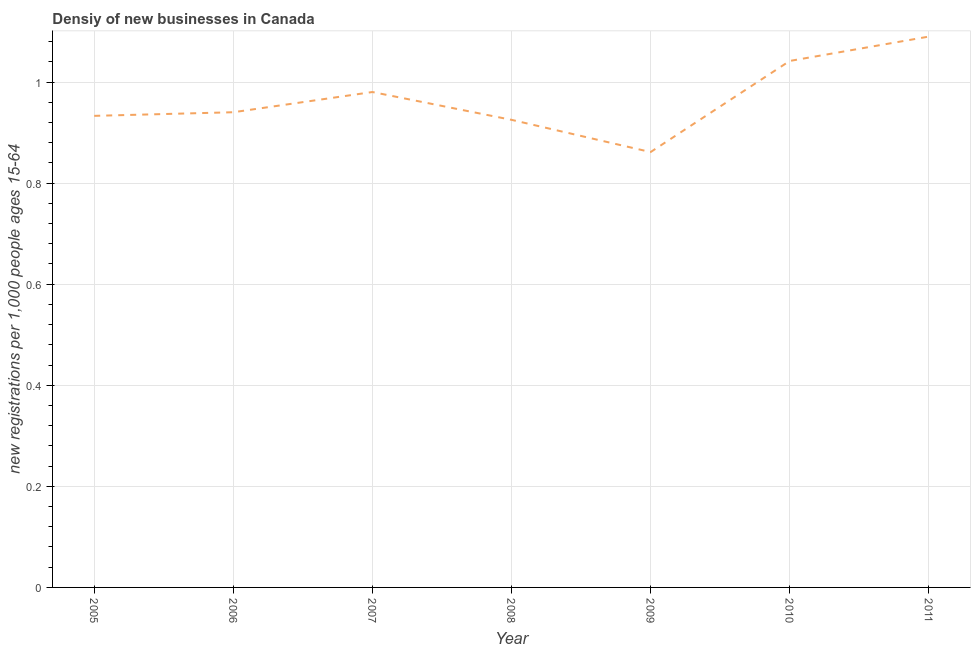What is the density of new business in 2007?
Offer a terse response. 0.98. Across all years, what is the maximum density of new business?
Keep it short and to the point. 1.09. Across all years, what is the minimum density of new business?
Your answer should be very brief. 0.86. What is the sum of the density of new business?
Provide a short and direct response. 6.77. What is the difference between the density of new business in 2005 and 2011?
Your answer should be very brief. -0.16. What is the average density of new business per year?
Your answer should be compact. 0.97. What is the median density of new business?
Your answer should be very brief. 0.94. In how many years, is the density of new business greater than 0.48000000000000004 ?
Provide a succinct answer. 7. What is the ratio of the density of new business in 2005 to that in 2006?
Provide a short and direct response. 0.99. Is the difference between the density of new business in 2005 and 2011 greater than the difference between any two years?
Provide a succinct answer. No. What is the difference between the highest and the second highest density of new business?
Keep it short and to the point. 0.05. Is the sum of the density of new business in 2005 and 2010 greater than the maximum density of new business across all years?
Your answer should be very brief. Yes. What is the difference between the highest and the lowest density of new business?
Your response must be concise. 0.23. How many years are there in the graph?
Keep it short and to the point. 7. Does the graph contain any zero values?
Ensure brevity in your answer.  No. What is the title of the graph?
Your response must be concise. Densiy of new businesses in Canada. What is the label or title of the Y-axis?
Your answer should be compact. New registrations per 1,0 people ages 15-64. What is the new registrations per 1,000 people ages 15-64 in 2005?
Ensure brevity in your answer.  0.93. What is the new registrations per 1,000 people ages 15-64 in 2006?
Provide a short and direct response. 0.94. What is the new registrations per 1,000 people ages 15-64 in 2007?
Keep it short and to the point. 0.98. What is the new registrations per 1,000 people ages 15-64 of 2008?
Your answer should be compact. 0.93. What is the new registrations per 1,000 people ages 15-64 in 2009?
Offer a very short reply. 0.86. What is the new registrations per 1,000 people ages 15-64 of 2010?
Ensure brevity in your answer.  1.04. What is the new registrations per 1,000 people ages 15-64 of 2011?
Your answer should be compact. 1.09. What is the difference between the new registrations per 1,000 people ages 15-64 in 2005 and 2006?
Provide a short and direct response. -0.01. What is the difference between the new registrations per 1,000 people ages 15-64 in 2005 and 2007?
Your response must be concise. -0.05. What is the difference between the new registrations per 1,000 people ages 15-64 in 2005 and 2008?
Give a very brief answer. 0.01. What is the difference between the new registrations per 1,000 people ages 15-64 in 2005 and 2009?
Offer a terse response. 0.07. What is the difference between the new registrations per 1,000 people ages 15-64 in 2005 and 2010?
Offer a very short reply. -0.11. What is the difference between the new registrations per 1,000 people ages 15-64 in 2005 and 2011?
Provide a short and direct response. -0.16. What is the difference between the new registrations per 1,000 people ages 15-64 in 2006 and 2007?
Your answer should be very brief. -0.04. What is the difference between the new registrations per 1,000 people ages 15-64 in 2006 and 2008?
Give a very brief answer. 0.02. What is the difference between the new registrations per 1,000 people ages 15-64 in 2006 and 2009?
Your answer should be very brief. 0.08. What is the difference between the new registrations per 1,000 people ages 15-64 in 2006 and 2010?
Your response must be concise. -0.1. What is the difference between the new registrations per 1,000 people ages 15-64 in 2006 and 2011?
Keep it short and to the point. -0.15. What is the difference between the new registrations per 1,000 people ages 15-64 in 2007 and 2008?
Your answer should be compact. 0.06. What is the difference between the new registrations per 1,000 people ages 15-64 in 2007 and 2009?
Offer a terse response. 0.12. What is the difference between the new registrations per 1,000 people ages 15-64 in 2007 and 2010?
Offer a terse response. -0.06. What is the difference between the new registrations per 1,000 people ages 15-64 in 2007 and 2011?
Give a very brief answer. -0.11. What is the difference between the new registrations per 1,000 people ages 15-64 in 2008 and 2009?
Provide a succinct answer. 0.06. What is the difference between the new registrations per 1,000 people ages 15-64 in 2008 and 2010?
Your answer should be very brief. -0.12. What is the difference between the new registrations per 1,000 people ages 15-64 in 2008 and 2011?
Offer a terse response. -0.16. What is the difference between the new registrations per 1,000 people ages 15-64 in 2009 and 2010?
Keep it short and to the point. -0.18. What is the difference between the new registrations per 1,000 people ages 15-64 in 2009 and 2011?
Ensure brevity in your answer.  -0.23. What is the difference between the new registrations per 1,000 people ages 15-64 in 2010 and 2011?
Provide a succinct answer. -0.05. What is the ratio of the new registrations per 1,000 people ages 15-64 in 2005 to that in 2006?
Provide a short and direct response. 0.99. What is the ratio of the new registrations per 1,000 people ages 15-64 in 2005 to that in 2007?
Your response must be concise. 0.95. What is the ratio of the new registrations per 1,000 people ages 15-64 in 2005 to that in 2008?
Keep it short and to the point. 1.01. What is the ratio of the new registrations per 1,000 people ages 15-64 in 2005 to that in 2009?
Your answer should be very brief. 1.08. What is the ratio of the new registrations per 1,000 people ages 15-64 in 2005 to that in 2010?
Offer a terse response. 0.9. What is the ratio of the new registrations per 1,000 people ages 15-64 in 2005 to that in 2011?
Your response must be concise. 0.86. What is the ratio of the new registrations per 1,000 people ages 15-64 in 2006 to that in 2008?
Offer a very short reply. 1.02. What is the ratio of the new registrations per 1,000 people ages 15-64 in 2006 to that in 2009?
Make the answer very short. 1.09. What is the ratio of the new registrations per 1,000 people ages 15-64 in 2006 to that in 2010?
Provide a succinct answer. 0.9. What is the ratio of the new registrations per 1,000 people ages 15-64 in 2006 to that in 2011?
Ensure brevity in your answer.  0.86. What is the ratio of the new registrations per 1,000 people ages 15-64 in 2007 to that in 2008?
Make the answer very short. 1.06. What is the ratio of the new registrations per 1,000 people ages 15-64 in 2007 to that in 2009?
Ensure brevity in your answer.  1.14. What is the ratio of the new registrations per 1,000 people ages 15-64 in 2007 to that in 2010?
Provide a succinct answer. 0.94. What is the ratio of the new registrations per 1,000 people ages 15-64 in 2007 to that in 2011?
Offer a very short reply. 0.9. What is the ratio of the new registrations per 1,000 people ages 15-64 in 2008 to that in 2009?
Give a very brief answer. 1.07. What is the ratio of the new registrations per 1,000 people ages 15-64 in 2008 to that in 2010?
Provide a short and direct response. 0.89. What is the ratio of the new registrations per 1,000 people ages 15-64 in 2008 to that in 2011?
Keep it short and to the point. 0.85. What is the ratio of the new registrations per 1,000 people ages 15-64 in 2009 to that in 2010?
Provide a succinct answer. 0.83. What is the ratio of the new registrations per 1,000 people ages 15-64 in 2009 to that in 2011?
Offer a very short reply. 0.79. What is the ratio of the new registrations per 1,000 people ages 15-64 in 2010 to that in 2011?
Offer a very short reply. 0.96. 